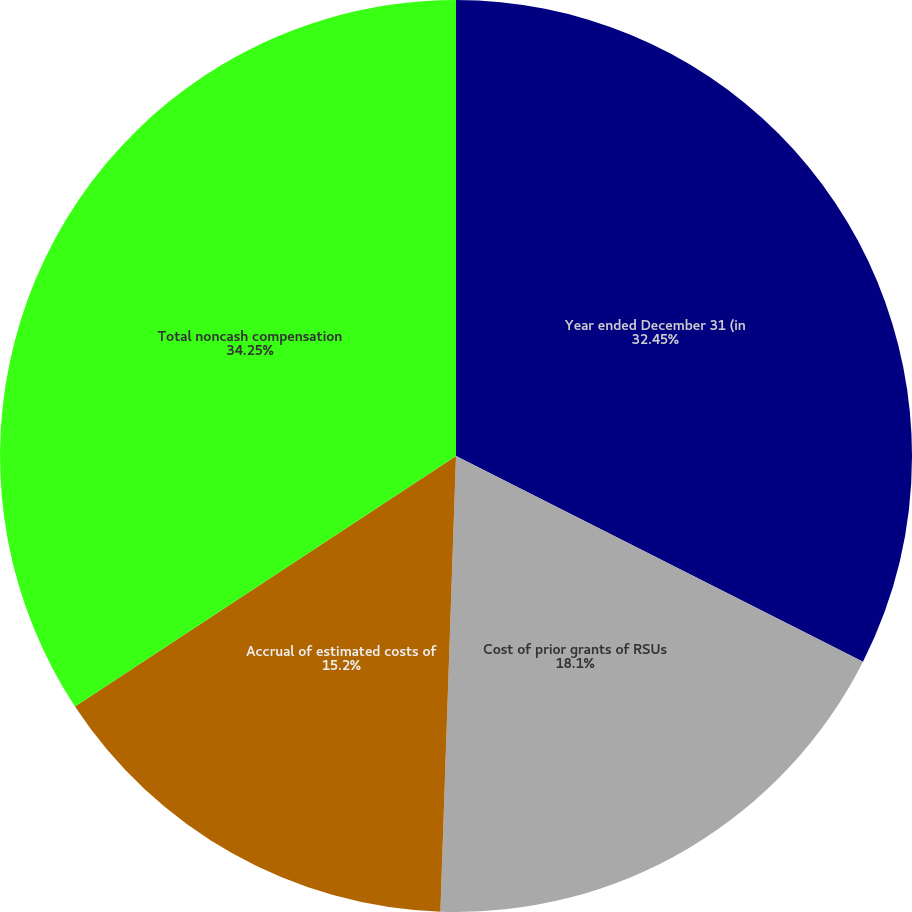Convert chart. <chart><loc_0><loc_0><loc_500><loc_500><pie_chart><fcel>Year ended December 31 (in<fcel>Cost of prior grants of RSUs<fcel>Accrual of estimated costs of<fcel>Total noncash compensation<nl><fcel>32.45%<fcel>18.1%<fcel>15.2%<fcel>34.26%<nl></chart> 